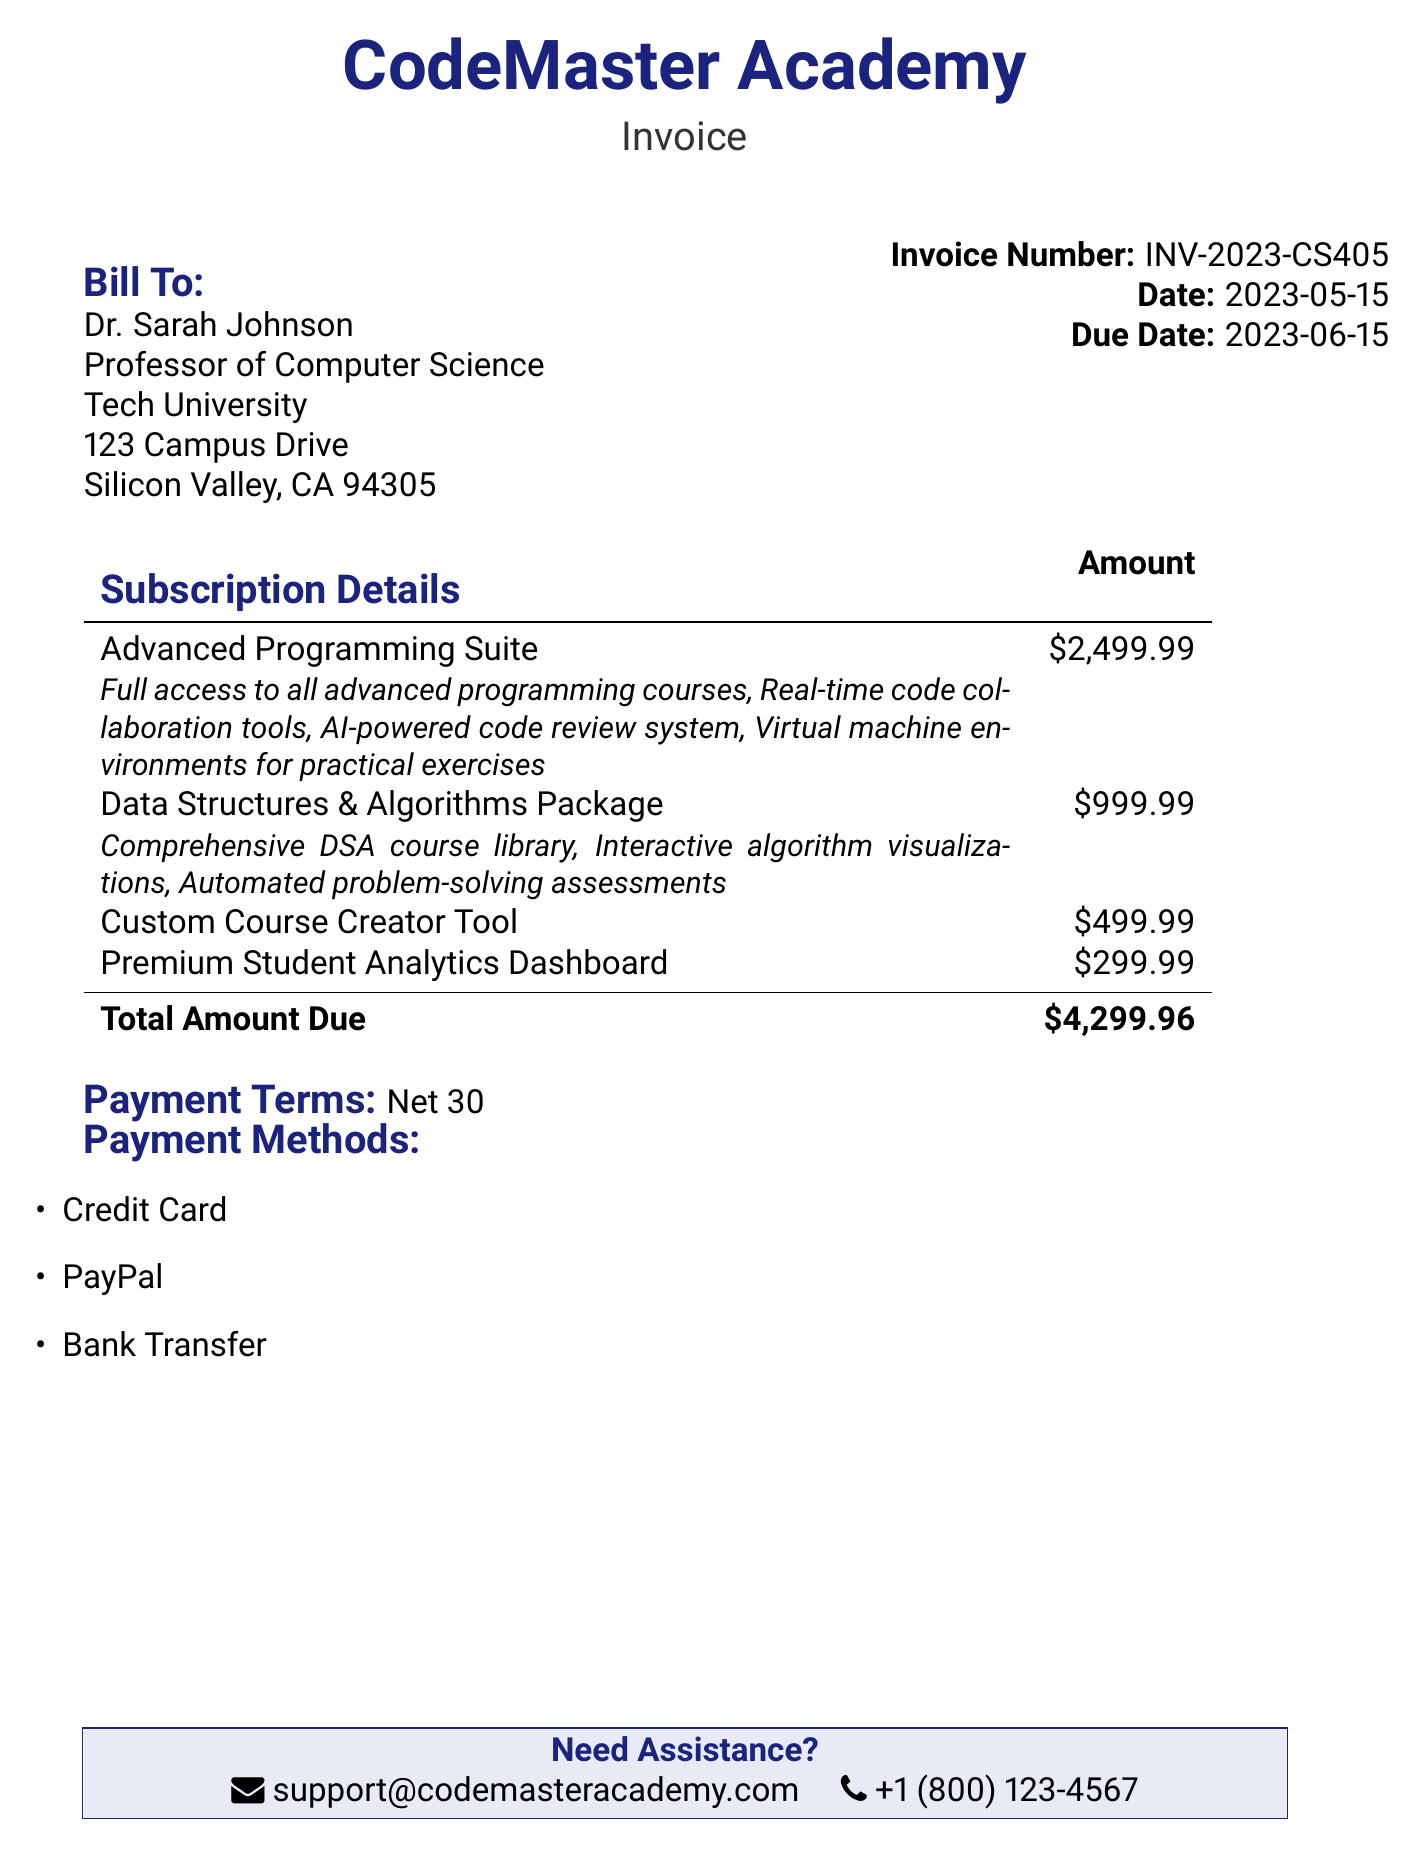What is the invoice number? The invoice number is explicitly stated in the document as INV-2023-CS405.
Answer: INV-2023-CS405 What is the due date for payment? The due date for the payment is mentioned as 2023-06-15 in the document.
Answer: 2023-06-15 How much does the Advanced Programming Suite cost? The cost of the Advanced Programming Suite is clearly listed as $2,499.99.
Answer: $2,499.99 Who is the bill addressed to? The bill is addressed to Dr. Sarah Johnson, as indicated in the billing information.
Answer: Dr. Sarah Johnson What are the payment methods listed? The document lists multiple payment methods including Credit Card, PayPal, and Bank Transfer.
Answer: Credit Card, PayPal, Bank Transfer What is the total amount due? The total amount due is calculated as the sum of all subscriptions, which amounts to $4,299.96.
Answer: $4,299.96 Which package includes real-time code collaboration tools? The Advanced Programming Suite specifically includes real-time code collaboration tools as part of its features.
Answer: Advanced Programming Suite What is the payment terms stated in the invoice? The payment terms mentioned in the invoice are specified as Net 30.
Answer: Net 30 What tool offers premium student analytics? The Premium Student Analytics Dashboard offers premium student analytics, as listed in the subscription details.
Answer: Premium Student Analytics Dashboard 